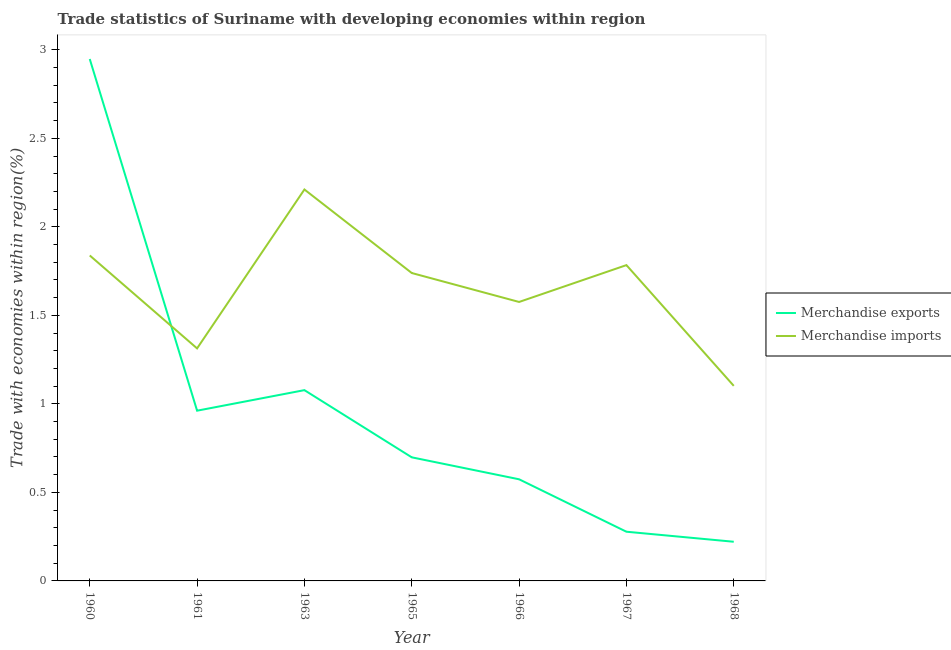What is the merchandise exports in 1967?
Make the answer very short. 0.28. Across all years, what is the maximum merchandise imports?
Offer a very short reply. 2.21. Across all years, what is the minimum merchandise exports?
Provide a succinct answer. 0.22. In which year was the merchandise imports minimum?
Ensure brevity in your answer.  1968. What is the total merchandise exports in the graph?
Your answer should be compact. 6.76. What is the difference between the merchandise exports in 1967 and that in 1968?
Give a very brief answer. 0.06. What is the difference between the merchandise imports in 1966 and the merchandise exports in 1960?
Offer a terse response. -1.37. What is the average merchandise exports per year?
Make the answer very short. 0.97. In the year 1961, what is the difference between the merchandise exports and merchandise imports?
Offer a very short reply. -0.35. What is the ratio of the merchandise exports in 1960 to that in 1968?
Give a very brief answer. 13.33. Is the merchandise exports in 1965 less than that in 1968?
Provide a succinct answer. No. Is the difference between the merchandise exports in 1967 and 1968 greater than the difference between the merchandise imports in 1967 and 1968?
Give a very brief answer. No. What is the difference between the highest and the second highest merchandise imports?
Provide a short and direct response. 0.37. What is the difference between the highest and the lowest merchandise exports?
Your answer should be compact. 2.73. In how many years, is the merchandise imports greater than the average merchandise imports taken over all years?
Your answer should be very brief. 4. Is the sum of the merchandise exports in 1965 and 1966 greater than the maximum merchandise imports across all years?
Keep it short and to the point. No. Does the merchandise exports monotonically increase over the years?
Your answer should be compact. No. How many lines are there?
Give a very brief answer. 2. How many years are there in the graph?
Your response must be concise. 7. What is the difference between two consecutive major ticks on the Y-axis?
Ensure brevity in your answer.  0.5. Are the values on the major ticks of Y-axis written in scientific E-notation?
Provide a succinct answer. No. Does the graph contain any zero values?
Keep it short and to the point. No. Where does the legend appear in the graph?
Provide a short and direct response. Center right. How are the legend labels stacked?
Offer a very short reply. Vertical. What is the title of the graph?
Keep it short and to the point. Trade statistics of Suriname with developing economies within region. What is the label or title of the Y-axis?
Make the answer very short. Trade with economies within region(%). What is the Trade with economies within region(%) in Merchandise exports in 1960?
Give a very brief answer. 2.95. What is the Trade with economies within region(%) of Merchandise imports in 1960?
Keep it short and to the point. 1.84. What is the Trade with economies within region(%) in Merchandise exports in 1961?
Provide a succinct answer. 0.96. What is the Trade with economies within region(%) of Merchandise imports in 1961?
Offer a very short reply. 1.31. What is the Trade with economies within region(%) of Merchandise exports in 1963?
Your answer should be very brief. 1.08. What is the Trade with economies within region(%) of Merchandise imports in 1963?
Give a very brief answer. 2.21. What is the Trade with economies within region(%) of Merchandise exports in 1965?
Keep it short and to the point. 0.7. What is the Trade with economies within region(%) in Merchandise imports in 1965?
Offer a terse response. 1.74. What is the Trade with economies within region(%) of Merchandise exports in 1966?
Give a very brief answer. 0.57. What is the Trade with economies within region(%) in Merchandise imports in 1966?
Give a very brief answer. 1.58. What is the Trade with economies within region(%) in Merchandise exports in 1967?
Your response must be concise. 0.28. What is the Trade with economies within region(%) in Merchandise imports in 1967?
Give a very brief answer. 1.78. What is the Trade with economies within region(%) of Merchandise exports in 1968?
Provide a short and direct response. 0.22. What is the Trade with economies within region(%) in Merchandise imports in 1968?
Your answer should be very brief. 1.1. Across all years, what is the maximum Trade with economies within region(%) in Merchandise exports?
Offer a terse response. 2.95. Across all years, what is the maximum Trade with economies within region(%) of Merchandise imports?
Offer a terse response. 2.21. Across all years, what is the minimum Trade with economies within region(%) in Merchandise exports?
Provide a short and direct response. 0.22. Across all years, what is the minimum Trade with economies within region(%) of Merchandise imports?
Offer a terse response. 1.1. What is the total Trade with economies within region(%) in Merchandise exports in the graph?
Your answer should be very brief. 6.76. What is the total Trade with economies within region(%) of Merchandise imports in the graph?
Provide a short and direct response. 11.56. What is the difference between the Trade with economies within region(%) in Merchandise exports in 1960 and that in 1961?
Offer a very short reply. 1.99. What is the difference between the Trade with economies within region(%) in Merchandise imports in 1960 and that in 1961?
Provide a short and direct response. 0.52. What is the difference between the Trade with economies within region(%) in Merchandise exports in 1960 and that in 1963?
Make the answer very short. 1.87. What is the difference between the Trade with economies within region(%) of Merchandise imports in 1960 and that in 1963?
Offer a very short reply. -0.37. What is the difference between the Trade with economies within region(%) in Merchandise exports in 1960 and that in 1965?
Offer a terse response. 2.25. What is the difference between the Trade with economies within region(%) of Merchandise imports in 1960 and that in 1965?
Keep it short and to the point. 0.1. What is the difference between the Trade with economies within region(%) of Merchandise exports in 1960 and that in 1966?
Keep it short and to the point. 2.37. What is the difference between the Trade with economies within region(%) of Merchandise imports in 1960 and that in 1966?
Provide a succinct answer. 0.26. What is the difference between the Trade with economies within region(%) of Merchandise exports in 1960 and that in 1967?
Provide a succinct answer. 2.67. What is the difference between the Trade with economies within region(%) in Merchandise imports in 1960 and that in 1967?
Keep it short and to the point. 0.05. What is the difference between the Trade with economies within region(%) in Merchandise exports in 1960 and that in 1968?
Give a very brief answer. 2.73. What is the difference between the Trade with economies within region(%) of Merchandise imports in 1960 and that in 1968?
Give a very brief answer. 0.74. What is the difference between the Trade with economies within region(%) in Merchandise exports in 1961 and that in 1963?
Provide a short and direct response. -0.12. What is the difference between the Trade with economies within region(%) in Merchandise imports in 1961 and that in 1963?
Your answer should be very brief. -0.9. What is the difference between the Trade with economies within region(%) in Merchandise exports in 1961 and that in 1965?
Your answer should be compact. 0.26. What is the difference between the Trade with economies within region(%) of Merchandise imports in 1961 and that in 1965?
Keep it short and to the point. -0.43. What is the difference between the Trade with economies within region(%) in Merchandise exports in 1961 and that in 1966?
Your response must be concise. 0.39. What is the difference between the Trade with economies within region(%) of Merchandise imports in 1961 and that in 1966?
Offer a terse response. -0.26. What is the difference between the Trade with economies within region(%) of Merchandise exports in 1961 and that in 1967?
Offer a terse response. 0.68. What is the difference between the Trade with economies within region(%) of Merchandise imports in 1961 and that in 1967?
Give a very brief answer. -0.47. What is the difference between the Trade with economies within region(%) of Merchandise exports in 1961 and that in 1968?
Offer a very short reply. 0.74. What is the difference between the Trade with economies within region(%) in Merchandise imports in 1961 and that in 1968?
Offer a very short reply. 0.21. What is the difference between the Trade with economies within region(%) in Merchandise exports in 1963 and that in 1965?
Offer a terse response. 0.38. What is the difference between the Trade with economies within region(%) of Merchandise imports in 1963 and that in 1965?
Make the answer very short. 0.47. What is the difference between the Trade with economies within region(%) in Merchandise exports in 1963 and that in 1966?
Offer a terse response. 0.5. What is the difference between the Trade with economies within region(%) of Merchandise imports in 1963 and that in 1966?
Ensure brevity in your answer.  0.64. What is the difference between the Trade with economies within region(%) of Merchandise exports in 1963 and that in 1967?
Provide a short and direct response. 0.8. What is the difference between the Trade with economies within region(%) in Merchandise imports in 1963 and that in 1967?
Ensure brevity in your answer.  0.43. What is the difference between the Trade with economies within region(%) in Merchandise exports in 1963 and that in 1968?
Your answer should be compact. 0.86. What is the difference between the Trade with economies within region(%) in Merchandise imports in 1963 and that in 1968?
Keep it short and to the point. 1.11. What is the difference between the Trade with economies within region(%) in Merchandise exports in 1965 and that in 1966?
Make the answer very short. 0.12. What is the difference between the Trade with economies within region(%) in Merchandise imports in 1965 and that in 1966?
Your answer should be compact. 0.16. What is the difference between the Trade with economies within region(%) in Merchandise exports in 1965 and that in 1967?
Give a very brief answer. 0.42. What is the difference between the Trade with economies within region(%) of Merchandise imports in 1965 and that in 1967?
Provide a succinct answer. -0.04. What is the difference between the Trade with economies within region(%) in Merchandise exports in 1965 and that in 1968?
Your response must be concise. 0.48. What is the difference between the Trade with economies within region(%) in Merchandise imports in 1965 and that in 1968?
Your answer should be very brief. 0.64. What is the difference between the Trade with economies within region(%) of Merchandise exports in 1966 and that in 1967?
Your response must be concise. 0.3. What is the difference between the Trade with economies within region(%) of Merchandise imports in 1966 and that in 1967?
Offer a terse response. -0.21. What is the difference between the Trade with economies within region(%) in Merchandise exports in 1966 and that in 1968?
Offer a very short reply. 0.35. What is the difference between the Trade with economies within region(%) in Merchandise imports in 1966 and that in 1968?
Your response must be concise. 0.47. What is the difference between the Trade with economies within region(%) of Merchandise exports in 1967 and that in 1968?
Offer a very short reply. 0.06. What is the difference between the Trade with economies within region(%) in Merchandise imports in 1967 and that in 1968?
Give a very brief answer. 0.68. What is the difference between the Trade with economies within region(%) in Merchandise exports in 1960 and the Trade with economies within region(%) in Merchandise imports in 1961?
Provide a short and direct response. 1.63. What is the difference between the Trade with economies within region(%) in Merchandise exports in 1960 and the Trade with economies within region(%) in Merchandise imports in 1963?
Make the answer very short. 0.74. What is the difference between the Trade with economies within region(%) in Merchandise exports in 1960 and the Trade with economies within region(%) in Merchandise imports in 1965?
Your response must be concise. 1.21. What is the difference between the Trade with economies within region(%) in Merchandise exports in 1960 and the Trade with economies within region(%) in Merchandise imports in 1966?
Give a very brief answer. 1.37. What is the difference between the Trade with economies within region(%) in Merchandise exports in 1960 and the Trade with economies within region(%) in Merchandise imports in 1967?
Make the answer very short. 1.16. What is the difference between the Trade with economies within region(%) of Merchandise exports in 1960 and the Trade with economies within region(%) of Merchandise imports in 1968?
Your response must be concise. 1.85. What is the difference between the Trade with economies within region(%) of Merchandise exports in 1961 and the Trade with economies within region(%) of Merchandise imports in 1963?
Offer a terse response. -1.25. What is the difference between the Trade with economies within region(%) in Merchandise exports in 1961 and the Trade with economies within region(%) in Merchandise imports in 1965?
Provide a short and direct response. -0.78. What is the difference between the Trade with economies within region(%) of Merchandise exports in 1961 and the Trade with economies within region(%) of Merchandise imports in 1966?
Your answer should be compact. -0.61. What is the difference between the Trade with economies within region(%) in Merchandise exports in 1961 and the Trade with economies within region(%) in Merchandise imports in 1967?
Offer a terse response. -0.82. What is the difference between the Trade with economies within region(%) of Merchandise exports in 1961 and the Trade with economies within region(%) of Merchandise imports in 1968?
Your answer should be very brief. -0.14. What is the difference between the Trade with economies within region(%) of Merchandise exports in 1963 and the Trade with economies within region(%) of Merchandise imports in 1965?
Your response must be concise. -0.66. What is the difference between the Trade with economies within region(%) in Merchandise exports in 1963 and the Trade with economies within region(%) in Merchandise imports in 1966?
Give a very brief answer. -0.5. What is the difference between the Trade with economies within region(%) in Merchandise exports in 1963 and the Trade with economies within region(%) in Merchandise imports in 1967?
Give a very brief answer. -0.71. What is the difference between the Trade with economies within region(%) in Merchandise exports in 1963 and the Trade with economies within region(%) in Merchandise imports in 1968?
Give a very brief answer. -0.02. What is the difference between the Trade with economies within region(%) in Merchandise exports in 1965 and the Trade with economies within region(%) in Merchandise imports in 1966?
Make the answer very short. -0.88. What is the difference between the Trade with economies within region(%) of Merchandise exports in 1965 and the Trade with economies within region(%) of Merchandise imports in 1967?
Keep it short and to the point. -1.09. What is the difference between the Trade with economies within region(%) of Merchandise exports in 1965 and the Trade with economies within region(%) of Merchandise imports in 1968?
Make the answer very short. -0.4. What is the difference between the Trade with economies within region(%) in Merchandise exports in 1966 and the Trade with economies within region(%) in Merchandise imports in 1967?
Offer a very short reply. -1.21. What is the difference between the Trade with economies within region(%) in Merchandise exports in 1966 and the Trade with economies within region(%) in Merchandise imports in 1968?
Give a very brief answer. -0.53. What is the difference between the Trade with economies within region(%) of Merchandise exports in 1967 and the Trade with economies within region(%) of Merchandise imports in 1968?
Make the answer very short. -0.82. What is the average Trade with economies within region(%) of Merchandise exports per year?
Offer a terse response. 0.97. What is the average Trade with economies within region(%) in Merchandise imports per year?
Offer a very short reply. 1.65. In the year 1960, what is the difference between the Trade with economies within region(%) in Merchandise exports and Trade with economies within region(%) in Merchandise imports?
Give a very brief answer. 1.11. In the year 1961, what is the difference between the Trade with economies within region(%) in Merchandise exports and Trade with economies within region(%) in Merchandise imports?
Provide a short and direct response. -0.35. In the year 1963, what is the difference between the Trade with economies within region(%) in Merchandise exports and Trade with economies within region(%) in Merchandise imports?
Your answer should be compact. -1.13. In the year 1965, what is the difference between the Trade with economies within region(%) of Merchandise exports and Trade with economies within region(%) of Merchandise imports?
Keep it short and to the point. -1.04. In the year 1966, what is the difference between the Trade with economies within region(%) in Merchandise exports and Trade with economies within region(%) in Merchandise imports?
Offer a very short reply. -1. In the year 1967, what is the difference between the Trade with economies within region(%) in Merchandise exports and Trade with economies within region(%) in Merchandise imports?
Offer a very short reply. -1.51. In the year 1968, what is the difference between the Trade with economies within region(%) of Merchandise exports and Trade with economies within region(%) of Merchandise imports?
Your answer should be compact. -0.88. What is the ratio of the Trade with economies within region(%) in Merchandise exports in 1960 to that in 1961?
Ensure brevity in your answer.  3.07. What is the ratio of the Trade with economies within region(%) of Merchandise imports in 1960 to that in 1961?
Make the answer very short. 1.4. What is the ratio of the Trade with economies within region(%) of Merchandise exports in 1960 to that in 1963?
Ensure brevity in your answer.  2.74. What is the ratio of the Trade with economies within region(%) of Merchandise imports in 1960 to that in 1963?
Keep it short and to the point. 0.83. What is the ratio of the Trade with economies within region(%) of Merchandise exports in 1960 to that in 1965?
Offer a terse response. 4.22. What is the ratio of the Trade with economies within region(%) in Merchandise imports in 1960 to that in 1965?
Ensure brevity in your answer.  1.06. What is the ratio of the Trade with economies within region(%) in Merchandise exports in 1960 to that in 1966?
Ensure brevity in your answer.  5.14. What is the ratio of the Trade with economies within region(%) of Merchandise imports in 1960 to that in 1966?
Give a very brief answer. 1.17. What is the ratio of the Trade with economies within region(%) of Merchandise exports in 1960 to that in 1967?
Your answer should be very brief. 10.61. What is the ratio of the Trade with economies within region(%) of Merchandise imports in 1960 to that in 1967?
Your answer should be very brief. 1.03. What is the ratio of the Trade with economies within region(%) of Merchandise exports in 1960 to that in 1968?
Offer a very short reply. 13.33. What is the ratio of the Trade with economies within region(%) in Merchandise imports in 1960 to that in 1968?
Your answer should be compact. 1.67. What is the ratio of the Trade with economies within region(%) in Merchandise exports in 1961 to that in 1963?
Your answer should be very brief. 0.89. What is the ratio of the Trade with economies within region(%) of Merchandise imports in 1961 to that in 1963?
Your response must be concise. 0.59. What is the ratio of the Trade with economies within region(%) in Merchandise exports in 1961 to that in 1965?
Keep it short and to the point. 1.38. What is the ratio of the Trade with economies within region(%) in Merchandise imports in 1961 to that in 1965?
Keep it short and to the point. 0.76. What is the ratio of the Trade with economies within region(%) in Merchandise exports in 1961 to that in 1966?
Your answer should be very brief. 1.68. What is the ratio of the Trade with economies within region(%) in Merchandise imports in 1961 to that in 1966?
Make the answer very short. 0.83. What is the ratio of the Trade with economies within region(%) in Merchandise exports in 1961 to that in 1967?
Your answer should be compact. 3.46. What is the ratio of the Trade with economies within region(%) in Merchandise imports in 1961 to that in 1967?
Provide a short and direct response. 0.74. What is the ratio of the Trade with economies within region(%) in Merchandise exports in 1961 to that in 1968?
Give a very brief answer. 4.35. What is the ratio of the Trade with economies within region(%) in Merchandise imports in 1961 to that in 1968?
Your answer should be compact. 1.19. What is the ratio of the Trade with economies within region(%) in Merchandise exports in 1963 to that in 1965?
Make the answer very short. 1.54. What is the ratio of the Trade with economies within region(%) in Merchandise imports in 1963 to that in 1965?
Your response must be concise. 1.27. What is the ratio of the Trade with economies within region(%) in Merchandise exports in 1963 to that in 1966?
Provide a short and direct response. 1.88. What is the ratio of the Trade with economies within region(%) of Merchandise imports in 1963 to that in 1966?
Give a very brief answer. 1.4. What is the ratio of the Trade with economies within region(%) in Merchandise exports in 1963 to that in 1967?
Keep it short and to the point. 3.88. What is the ratio of the Trade with economies within region(%) in Merchandise imports in 1963 to that in 1967?
Your answer should be very brief. 1.24. What is the ratio of the Trade with economies within region(%) of Merchandise exports in 1963 to that in 1968?
Provide a succinct answer. 4.87. What is the ratio of the Trade with economies within region(%) in Merchandise imports in 1963 to that in 1968?
Give a very brief answer. 2.01. What is the ratio of the Trade with economies within region(%) of Merchandise exports in 1965 to that in 1966?
Give a very brief answer. 1.22. What is the ratio of the Trade with economies within region(%) in Merchandise imports in 1965 to that in 1966?
Keep it short and to the point. 1.1. What is the ratio of the Trade with economies within region(%) of Merchandise exports in 1965 to that in 1967?
Your response must be concise. 2.51. What is the ratio of the Trade with economies within region(%) in Merchandise imports in 1965 to that in 1967?
Offer a terse response. 0.97. What is the ratio of the Trade with economies within region(%) in Merchandise exports in 1965 to that in 1968?
Offer a very short reply. 3.16. What is the ratio of the Trade with economies within region(%) of Merchandise imports in 1965 to that in 1968?
Keep it short and to the point. 1.58. What is the ratio of the Trade with economies within region(%) in Merchandise exports in 1966 to that in 1967?
Provide a succinct answer. 2.07. What is the ratio of the Trade with economies within region(%) in Merchandise imports in 1966 to that in 1967?
Give a very brief answer. 0.88. What is the ratio of the Trade with economies within region(%) in Merchandise exports in 1966 to that in 1968?
Keep it short and to the point. 2.59. What is the ratio of the Trade with economies within region(%) of Merchandise imports in 1966 to that in 1968?
Make the answer very short. 1.43. What is the ratio of the Trade with economies within region(%) in Merchandise exports in 1967 to that in 1968?
Provide a succinct answer. 1.26. What is the ratio of the Trade with economies within region(%) in Merchandise imports in 1967 to that in 1968?
Provide a succinct answer. 1.62. What is the difference between the highest and the second highest Trade with economies within region(%) in Merchandise exports?
Ensure brevity in your answer.  1.87. What is the difference between the highest and the second highest Trade with economies within region(%) of Merchandise imports?
Keep it short and to the point. 0.37. What is the difference between the highest and the lowest Trade with economies within region(%) in Merchandise exports?
Keep it short and to the point. 2.73. What is the difference between the highest and the lowest Trade with economies within region(%) in Merchandise imports?
Offer a very short reply. 1.11. 